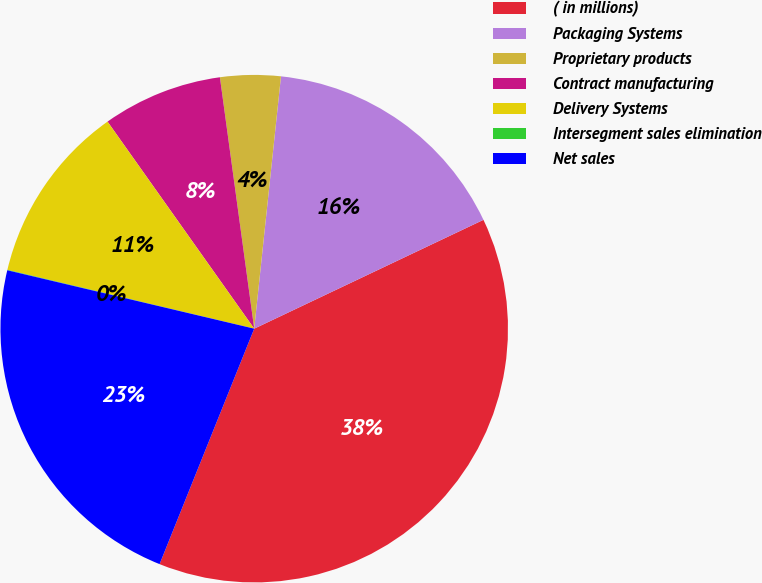Convert chart to OTSL. <chart><loc_0><loc_0><loc_500><loc_500><pie_chart><fcel>( in millions)<fcel>Packaging Systems<fcel>Proprietary products<fcel>Contract manufacturing<fcel>Delivery Systems<fcel>Intersegment sales elimination<fcel>Net sales<nl><fcel>38.13%<fcel>16.26%<fcel>3.84%<fcel>7.65%<fcel>11.46%<fcel>0.03%<fcel>22.61%<nl></chart> 